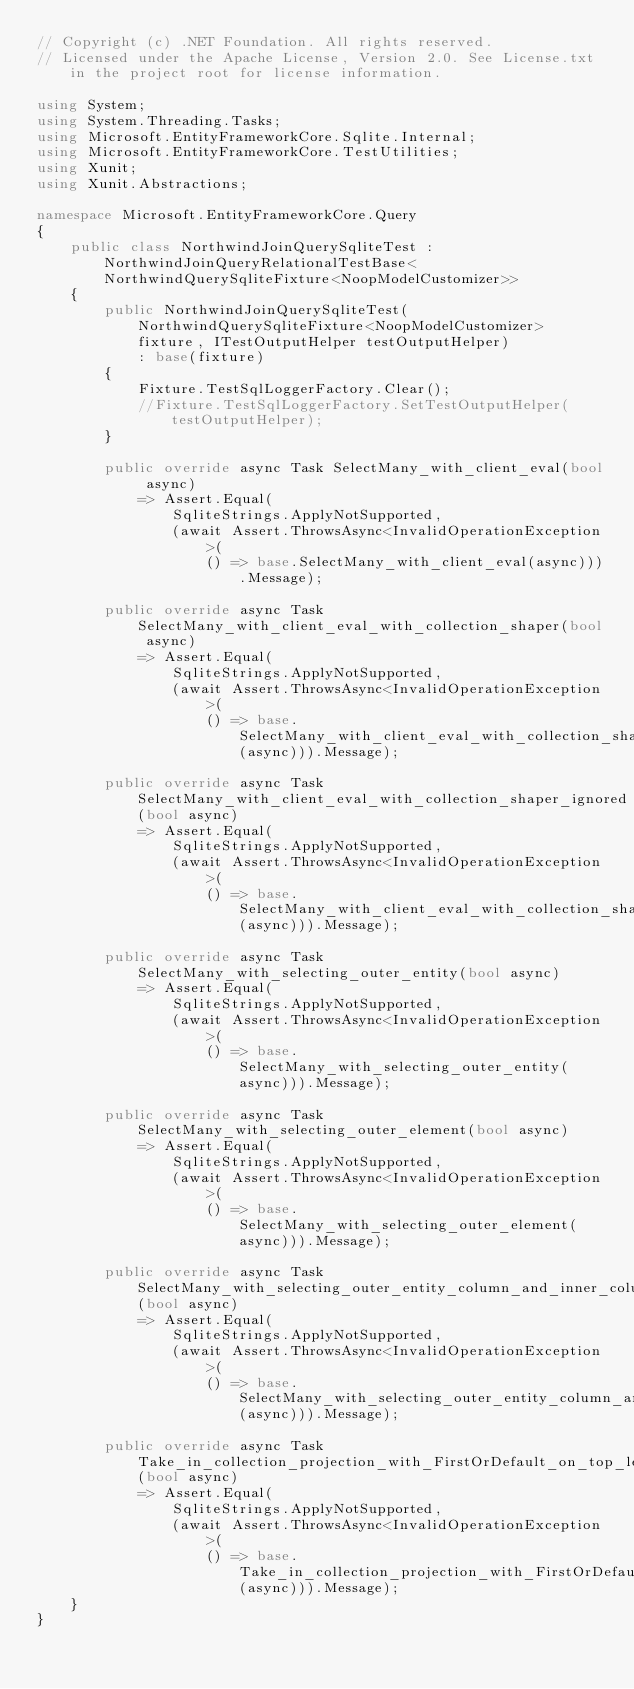<code> <loc_0><loc_0><loc_500><loc_500><_C#_>// Copyright (c) .NET Foundation. All rights reserved.
// Licensed under the Apache License, Version 2.0. See License.txt in the project root for license information.

using System;
using System.Threading.Tasks;
using Microsoft.EntityFrameworkCore.Sqlite.Internal;
using Microsoft.EntityFrameworkCore.TestUtilities;
using Xunit;
using Xunit.Abstractions;

namespace Microsoft.EntityFrameworkCore.Query
{
    public class NorthwindJoinQuerySqliteTest : NorthwindJoinQueryRelationalTestBase<NorthwindQuerySqliteFixture<NoopModelCustomizer>>
    {
        public NorthwindJoinQuerySqliteTest(NorthwindQuerySqliteFixture<NoopModelCustomizer> fixture, ITestOutputHelper testOutputHelper)
            : base(fixture)
        {
            Fixture.TestSqlLoggerFactory.Clear();
            //Fixture.TestSqlLoggerFactory.SetTestOutputHelper(testOutputHelper);
        }

        public override async Task SelectMany_with_client_eval(bool async)
            => Assert.Equal(
                SqliteStrings.ApplyNotSupported,
                (await Assert.ThrowsAsync<InvalidOperationException>(
                    () => base.SelectMany_with_client_eval(async))).Message);

        public override async Task SelectMany_with_client_eval_with_collection_shaper(bool async)
            => Assert.Equal(
                SqliteStrings.ApplyNotSupported,
                (await Assert.ThrowsAsync<InvalidOperationException>(
                    () => base.SelectMany_with_client_eval_with_collection_shaper(async))).Message);

        public override async Task SelectMany_with_client_eval_with_collection_shaper_ignored(bool async)
            => Assert.Equal(
                SqliteStrings.ApplyNotSupported,
                (await Assert.ThrowsAsync<InvalidOperationException>(
                    () => base.SelectMany_with_client_eval_with_collection_shaper_ignored(async))).Message);

        public override async Task SelectMany_with_selecting_outer_entity(bool async)
            => Assert.Equal(
                SqliteStrings.ApplyNotSupported,
                (await Assert.ThrowsAsync<InvalidOperationException>(
                    () => base.SelectMany_with_selecting_outer_entity(async))).Message);

        public override async Task SelectMany_with_selecting_outer_element(bool async)
            => Assert.Equal(
                SqliteStrings.ApplyNotSupported,
                (await Assert.ThrowsAsync<InvalidOperationException>(
                    () => base.SelectMany_with_selecting_outer_element(async))).Message);

        public override async Task SelectMany_with_selecting_outer_entity_column_and_inner_column(bool async)
            => Assert.Equal(
                SqliteStrings.ApplyNotSupported,
                (await Assert.ThrowsAsync<InvalidOperationException>(
                    () => base.SelectMany_with_selecting_outer_entity_column_and_inner_column(async))).Message);

        public override async Task Take_in_collection_projection_with_FirstOrDefault_on_top_level(bool async)
            => Assert.Equal(
                SqliteStrings.ApplyNotSupported,
                (await Assert.ThrowsAsync<InvalidOperationException>(
                    () => base.Take_in_collection_projection_with_FirstOrDefault_on_top_level(async))).Message);
    }
}
</code> 